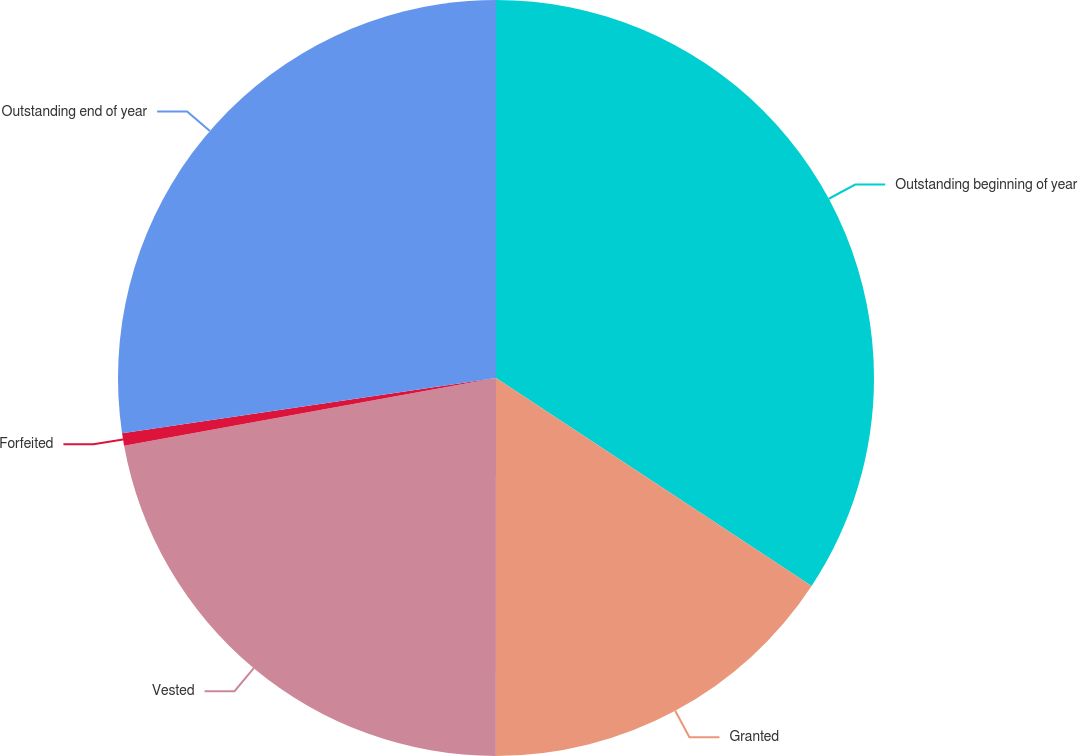<chart> <loc_0><loc_0><loc_500><loc_500><pie_chart><fcel>Outstanding beginning of year<fcel>Granted<fcel>Vested<fcel>Forfeited<fcel>Outstanding end of year<nl><fcel>34.27%<fcel>15.73%<fcel>22.13%<fcel>0.53%<fcel>27.33%<nl></chart> 